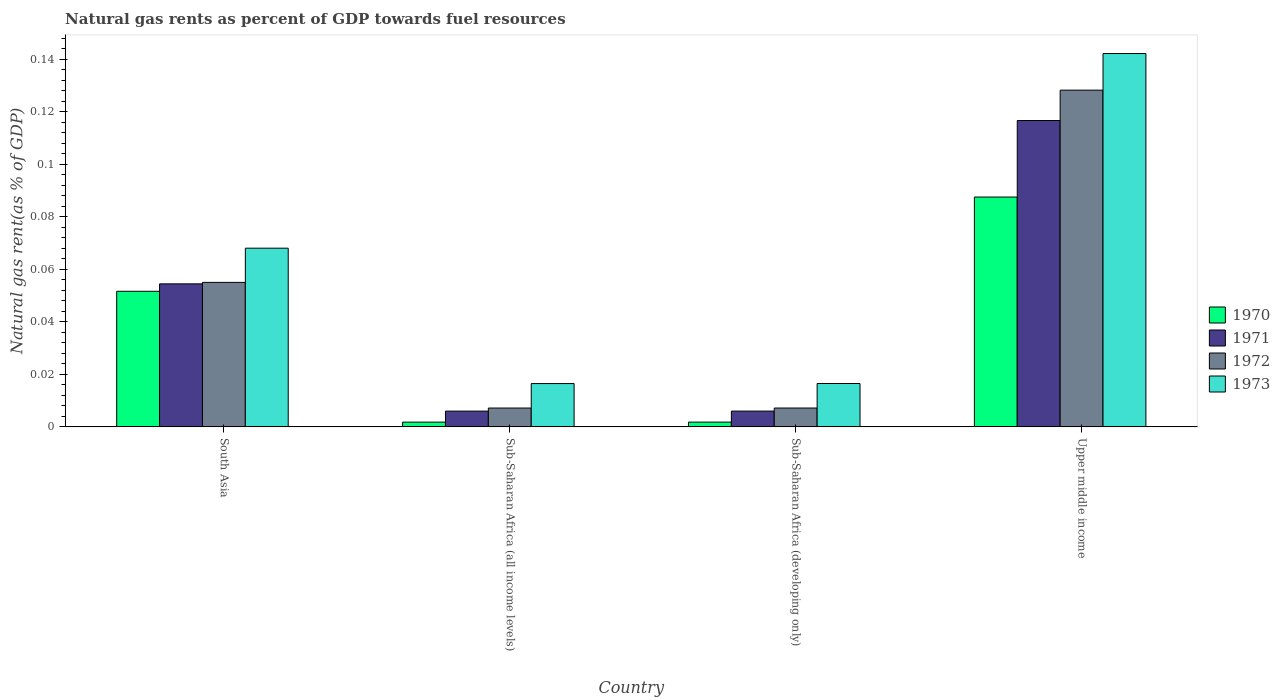How many different coloured bars are there?
Keep it short and to the point. 4. How many groups of bars are there?
Your response must be concise. 4. Are the number of bars per tick equal to the number of legend labels?
Provide a succinct answer. Yes. Are the number of bars on each tick of the X-axis equal?
Give a very brief answer. Yes. What is the label of the 1st group of bars from the left?
Keep it short and to the point. South Asia. What is the natural gas rent in 1971 in Sub-Saharan Africa (developing only)?
Give a very brief answer. 0.01. Across all countries, what is the maximum natural gas rent in 1973?
Your response must be concise. 0.14. Across all countries, what is the minimum natural gas rent in 1971?
Give a very brief answer. 0.01. In which country was the natural gas rent in 1973 maximum?
Your answer should be very brief. Upper middle income. In which country was the natural gas rent in 1971 minimum?
Provide a short and direct response. Sub-Saharan Africa (all income levels). What is the total natural gas rent in 1973 in the graph?
Your answer should be compact. 0.24. What is the difference between the natural gas rent in 1970 in South Asia and that in Upper middle income?
Provide a short and direct response. -0.04. What is the difference between the natural gas rent in 1972 in Sub-Saharan Africa (developing only) and the natural gas rent in 1973 in South Asia?
Your answer should be very brief. -0.06. What is the average natural gas rent in 1970 per country?
Offer a terse response. 0.04. What is the difference between the natural gas rent of/in 1971 and natural gas rent of/in 1970 in Upper middle income?
Provide a succinct answer. 0.03. What is the ratio of the natural gas rent in 1971 in Sub-Saharan Africa (all income levels) to that in Sub-Saharan Africa (developing only)?
Offer a very short reply. 1. Is the natural gas rent in 1973 in South Asia less than that in Sub-Saharan Africa (all income levels)?
Ensure brevity in your answer.  No. Is the difference between the natural gas rent in 1971 in South Asia and Upper middle income greater than the difference between the natural gas rent in 1970 in South Asia and Upper middle income?
Provide a short and direct response. No. What is the difference between the highest and the second highest natural gas rent in 1970?
Keep it short and to the point. 0.09. What is the difference between the highest and the lowest natural gas rent in 1971?
Your answer should be very brief. 0.11. Is the sum of the natural gas rent in 1971 in Sub-Saharan Africa (all income levels) and Upper middle income greater than the maximum natural gas rent in 1970 across all countries?
Your response must be concise. Yes. Is it the case that in every country, the sum of the natural gas rent in 1970 and natural gas rent in 1973 is greater than the sum of natural gas rent in 1971 and natural gas rent in 1972?
Ensure brevity in your answer.  No. What does the 2nd bar from the right in South Asia represents?
Keep it short and to the point. 1972. Are all the bars in the graph horizontal?
Your answer should be compact. No. What is the difference between two consecutive major ticks on the Y-axis?
Your response must be concise. 0.02. Are the values on the major ticks of Y-axis written in scientific E-notation?
Keep it short and to the point. No. Does the graph contain any zero values?
Your response must be concise. No. Does the graph contain grids?
Provide a short and direct response. No. Where does the legend appear in the graph?
Ensure brevity in your answer.  Center right. How many legend labels are there?
Your answer should be very brief. 4. How are the legend labels stacked?
Give a very brief answer. Vertical. What is the title of the graph?
Make the answer very short. Natural gas rents as percent of GDP towards fuel resources. What is the label or title of the X-axis?
Offer a terse response. Country. What is the label or title of the Y-axis?
Provide a succinct answer. Natural gas rent(as % of GDP). What is the Natural gas rent(as % of GDP) in 1970 in South Asia?
Offer a very short reply. 0.05. What is the Natural gas rent(as % of GDP) of 1971 in South Asia?
Keep it short and to the point. 0.05. What is the Natural gas rent(as % of GDP) in 1972 in South Asia?
Provide a short and direct response. 0.06. What is the Natural gas rent(as % of GDP) in 1973 in South Asia?
Give a very brief answer. 0.07. What is the Natural gas rent(as % of GDP) in 1970 in Sub-Saharan Africa (all income levels)?
Offer a terse response. 0. What is the Natural gas rent(as % of GDP) in 1971 in Sub-Saharan Africa (all income levels)?
Ensure brevity in your answer.  0.01. What is the Natural gas rent(as % of GDP) of 1972 in Sub-Saharan Africa (all income levels)?
Give a very brief answer. 0.01. What is the Natural gas rent(as % of GDP) in 1973 in Sub-Saharan Africa (all income levels)?
Your response must be concise. 0.02. What is the Natural gas rent(as % of GDP) in 1970 in Sub-Saharan Africa (developing only)?
Your answer should be very brief. 0. What is the Natural gas rent(as % of GDP) in 1971 in Sub-Saharan Africa (developing only)?
Your response must be concise. 0.01. What is the Natural gas rent(as % of GDP) of 1972 in Sub-Saharan Africa (developing only)?
Offer a terse response. 0.01. What is the Natural gas rent(as % of GDP) of 1973 in Sub-Saharan Africa (developing only)?
Provide a succinct answer. 0.02. What is the Natural gas rent(as % of GDP) in 1970 in Upper middle income?
Offer a terse response. 0.09. What is the Natural gas rent(as % of GDP) of 1971 in Upper middle income?
Your answer should be compact. 0.12. What is the Natural gas rent(as % of GDP) of 1972 in Upper middle income?
Offer a terse response. 0.13. What is the Natural gas rent(as % of GDP) of 1973 in Upper middle income?
Your answer should be compact. 0.14. Across all countries, what is the maximum Natural gas rent(as % of GDP) of 1970?
Make the answer very short. 0.09. Across all countries, what is the maximum Natural gas rent(as % of GDP) of 1971?
Offer a very short reply. 0.12. Across all countries, what is the maximum Natural gas rent(as % of GDP) of 1972?
Your answer should be compact. 0.13. Across all countries, what is the maximum Natural gas rent(as % of GDP) of 1973?
Your answer should be compact. 0.14. Across all countries, what is the minimum Natural gas rent(as % of GDP) in 1970?
Make the answer very short. 0. Across all countries, what is the minimum Natural gas rent(as % of GDP) of 1971?
Provide a short and direct response. 0.01. Across all countries, what is the minimum Natural gas rent(as % of GDP) of 1972?
Make the answer very short. 0.01. Across all countries, what is the minimum Natural gas rent(as % of GDP) of 1973?
Give a very brief answer. 0.02. What is the total Natural gas rent(as % of GDP) in 1970 in the graph?
Offer a terse response. 0.14. What is the total Natural gas rent(as % of GDP) of 1971 in the graph?
Offer a terse response. 0.18. What is the total Natural gas rent(as % of GDP) of 1972 in the graph?
Your answer should be compact. 0.2. What is the total Natural gas rent(as % of GDP) in 1973 in the graph?
Provide a succinct answer. 0.24. What is the difference between the Natural gas rent(as % of GDP) in 1970 in South Asia and that in Sub-Saharan Africa (all income levels)?
Your answer should be compact. 0.05. What is the difference between the Natural gas rent(as % of GDP) of 1971 in South Asia and that in Sub-Saharan Africa (all income levels)?
Your answer should be very brief. 0.05. What is the difference between the Natural gas rent(as % of GDP) in 1972 in South Asia and that in Sub-Saharan Africa (all income levels)?
Your answer should be very brief. 0.05. What is the difference between the Natural gas rent(as % of GDP) of 1973 in South Asia and that in Sub-Saharan Africa (all income levels)?
Your answer should be compact. 0.05. What is the difference between the Natural gas rent(as % of GDP) in 1970 in South Asia and that in Sub-Saharan Africa (developing only)?
Make the answer very short. 0.05. What is the difference between the Natural gas rent(as % of GDP) in 1971 in South Asia and that in Sub-Saharan Africa (developing only)?
Give a very brief answer. 0.05. What is the difference between the Natural gas rent(as % of GDP) in 1972 in South Asia and that in Sub-Saharan Africa (developing only)?
Provide a short and direct response. 0.05. What is the difference between the Natural gas rent(as % of GDP) of 1973 in South Asia and that in Sub-Saharan Africa (developing only)?
Ensure brevity in your answer.  0.05. What is the difference between the Natural gas rent(as % of GDP) of 1970 in South Asia and that in Upper middle income?
Keep it short and to the point. -0.04. What is the difference between the Natural gas rent(as % of GDP) in 1971 in South Asia and that in Upper middle income?
Your answer should be very brief. -0.06. What is the difference between the Natural gas rent(as % of GDP) in 1972 in South Asia and that in Upper middle income?
Provide a short and direct response. -0.07. What is the difference between the Natural gas rent(as % of GDP) of 1973 in South Asia and that in Upper middle income?
Keep it short and to the point. -0.07. What is the difference between the Natural gas rent(as % of GDP) in 1971 in Sub-Saharan Africa (all income levels) and that in Sub-Saharan Africa (developing only)?
Keep it short and to the point. -0. What is the difference between the Natural gas rent(as % of GDP) of 1972 in Sub-Saharan Africa (all income levels) and that in Sub-Saharan Africa (developing only)?
Keep it short and to the point. -0. What is the difference between the Natural gas rent(as % of GDP) of 1973 in Sub-Saharan Africa (all income levels) and that in Sub-Saharan Africa (developing only)?
Provide a succinct answer. -0. What is the difference between the Natural gas rent(as % of GDP) in 1970 in Sub-Saharan Africa (all income levels) and that in Upper middle income?
Ensure brevity in your answer.  -0.09. What is the difference between the Natural gas rent(as % of GDP) of 1971 in Sub-Saharan Africa (all income levels) and that in Upper middle income?
Offer a very short reply. -0.11. What is the difference between the Natural gas rent(as % of GDP) in 1972 in Sub-Saharan Africa (all income levels) and that in Upper middle income?
Ensure brevity in your answer.  -0.12. What is the difference between the Natural gas rent(as % of GDP) of 1973 in Sub-Saharan Africa (all income levels) and that in Upper middle income?
Your response must be concise. -0.13. What is the difference between the Natural gas rent(as % of GDP) in 1970 in Sub-Saharan Africa (developing only) and that in Upper middle income?
Offer a terse response. -0.09. What is the difference between the Natural gas rent(as % of GDP) in 1971 in Sub-Saharan Africa (developing only) and that in Upper middle income?
Make the answer very short. -0.11. What is the difference between the Natural gas rent(as % of GDP) in 1972 in Sub-Saharan Africa (developing only) and that in Upper middle income?
Keep it short and to the point. -0.12. What is the difference between the Natural gas rent(as % of GDP) of 1973 in Sub-Saharan Africa (developing only) and that in Upper middle income?
Your answer should be compact. -0.13. What is the difference between the Natural gas rent(as % of GDP) of 1970 in South Asia and the Natural gas rent(as % of GDP) of 1971 in Sub-Saharan Africa (all income levels)?
Provide a short and direct response. 0.05. What is the difference between the Natural gas rent(as % of GDP) of 1970 in South Asia and the Natural gas rent(as % of GDP) of 1972 in Sub-Saharan Africa (all income levels)?
Offer a terse response. 0.04. What is the difference between the Natural gas rent(as % of GDP) of 1970 in South Asia and the Natural gas rent(as % of GDP) of 1973 in Sub-Saharan Africa (all income levels)?
Provide a short and direct response. 0.04. What is the difference between the Natural gas rent(as % of GDP) in 1971 in South Asia and the Natural gas rent(as % of GDP) in 1972 in Sub-Saharan Africa (all income levels)?
Your response must be concise. 0.05. What is the difference between the Natural gas rent(as % of GDP) in 1971 in South Asia and the Natural gas rent(as % of GDP) in 1973 in Sub-Saharan Africa (all income levels)?
Ensure brevity in your answer.  0.04. What is the difference between the Natural gas rent(as % of GDP) of 1972 in South Asia and the Natural gas rent(as % of GDP) of 1973 in Sub-Saharan Africa (all income levels)?
Your response must be concise. 0.04. What is the difference between the Natural gas rent(as % of GDP) of 1970 in South Asia and the Natural gas rent(as % of GDP) of 1971 in Sub-Saharan Africa (developing only)?
Offer a terse response. 0.05. What is the difference between the Natural gas rent(as % of GDP) of 1970 in South Asia and the Natural gas rent(as % of GDP) of 1972 in Sub-Saharan Africa (developing only)?
Make the answer very short. 0.04. What is the difference between the Natural gas rent(as % of GDP) of 1970 in South Asia and the Natural gas rent(as % of GDP) of 1973 in Sub-Saharan Africa (developing only)?
Offer a very short reply. 0.04. What is the difference between the Natural gas rent(as % of GDP) of 1971 in South Asia and the Natural gas rent(as % of GDP) of 1972 in Sub-Saharan Africa (developing only)?
Offer a terse response. 0.05. What is the difference between the Natural gas rent(as % of GDP) in 1971 in South Asia and the Natural gas rent(as % of GDP) in 1973 in Sub-Saharan Africa (developing only)?
Give a very brief answer. 0.04. What is the difference between the Natural gas rent(as % of GDP) of 1972 in South Asia and the Natural gas rent(as % of GDP) of 1973 in Sub-Saharan Africa (developing only)?
Make the answer very short. 0.04. What is the difference between the Natural gas rent(as % of GDP) of 1970 in South Asia and the Natural gas rent(as % of GDP) of 1971 in Upper middle income?
Ensure brevity in your answer.  -0.07. What is the difference between the Natural gas rent(as % of GDP) of 1970 in South Asia and the Natural gas rent(as % of GDP) of 1972 in Upper middle income?
Ensure brevity in your answer.  -0.08. What is the difference between the Natural gas rent(as % of GDP) of 1970 in South Asia and the Natural gas rent(as % of GDP) of 1973 in Upper middle income?
Keep it short and to the point. -0.09. What is the difference between the Natural gas rent(as % of GDP) in 1971 in South Asia and the Natural gas rent(as % of GDP) in 1972 in Upper middle income?
Provide a succinct answer. -0.07. What is the difference between the Natural gas rent(as % of GDP) in 1971 in South Asia and the Natural gas rent(as % of GDP) in 1973 in Upper middle income?
Keep it short and to the point. -0.09. What is the difference between the Natural gas rent(as % of GDP) of 1972 in South Asia and the Natural gas rent(as % of GDP) of 1973 in Upper middle income?
Offer a very short reply. -0.09. What is the difference between the Natural gas rent(as % of GDP) of 1970 in Sub-Saharan Africa (all income levels) and the Natural gas rent(as % of GDP) of 1971 in Sub-Saharan Africa (developing only)?
Ensure brevity in your answer.  -0. What is the difference between the Natural gas rent(as % of GDP) of 1970 in Sub-Saharan Africa (all income levels) and the Natural gas rent(as % of GDP) of 1972 in Sub-Saharan Africa (developing only)?
Offer a very short reply. -0.01. What is the difference between the Natural gas rent(as % of GDP) in 1970 in Sub-Saharan Africa (all income levels) and the Natural gas rent(as % of GDP) in 1973 in Sub-Saharan Africa (developing only)?
Your response must be concise. -0.01. What is the difference between the Natural gas rent(as % of GDP) in 1971 in Sub-Saharan Africa (all income levels) and the Natural gas rent(as % of GDP) in 1972 in Sub-Saharan Africa (developing only)?
Provide a succinct answer. -0. What is the difference between the Natural gas rent(as % of GDP) of 1971 in Sub-Saharan Africa (all income levels) and the Natural gas rent(as % of GDP) of 1973 in Sub-Saharan Africa (developing only)?
Your answer should be compact. -0.01. What is the difference between the Natural gas rent(as % of GDP) in 1972 in Sub-Saharan Africa (all income levels) and the Natural gas rent(as % of GDP) in 1973 in Sub-Saharan Africa (developing only)?
Provide a succinct answer. -0.01. What is the difference between the Natural gas rent(as % of GDP) in 1970 in Sub-Saharan Africa (all income levels) and the Natural gas rent(as % of GDP) in 1971 in Upper middle income?
Ensure brevity in your answer.  -0.11. What is the difference between the Natural gas rent(as % of GDP) in 1970 in Sub-Saharan Africa (all income levels) and the Natural gas rent(as % of GDP) in 1972 in Upper middle income?
Your response must be concise. -0.13. What is the difference between the Natural gas rent(as % of GDP) in 1970 in Sub-Saharan Africa (all income levels) and the Natural gas rent(as % of GDP) in 1973 in Upper middle income?
Keep it short and to the point. -0.14. What is the difference between the Natural gas rent(as % of GDP) in 1971 in Sub-Saharan Africa (all income levels) and the Natural gas rent(as % of GDP) in 1972 in Upper middle income?
Your response must be concise. -0.12. What is the difference between the Natural gas rent(as % of GDP) of 1971 in Sub-Saharan Africa (all income levels) and the Natural gas rent(as % of GDP) of 1973 in Upper middle income?
Provide a succinct answer. -0.14. What is the difference between the Natural gas rent(as % of GDP) in 1972 in Sub-Saharan Africa (all income levels) and the Natural gas rent(as % of GDP) in 1973 in Upper middle income?
Your answer should be compact. -0.14. What is the difference between the Natural gas rent(as % of GDP) in 1970 in Sub-Saharan Africa (developing only) and the Natural gas rent(as % of GDP) in 1971 in Upper middle income?
Your answer should be very brief. -0.11. What is the difference between the Natural gas rent(as % of GDP) of 1970 in Sub-Saharan Africa (developing only) and the Natural gas rent(as % of GDP) of 1972 in Upper middle income?
Offer a very short reply. -0.13. What is the difference between the Natural gas rent(as % of GDP) in 1970 in Sub-Saharan Africa (developing only) and the Natural gas rent(as % of GDP) in 1973 in Upper middle income?
Give a very brief answer. -0.14. What is the difference between the Natural gas rent(as % of GDP) of 1971 in Sub-Saharan Africa (developing only) and the Natural gas rent(as % of GDP) of 1972 in Upper middle income?
Offer a terse response. -0.12. What is the difference between the Natural gas rent(as % of GDP) in 1971 in Sub-Saharan Africa (developing only) and the Natural gas rent(as % of GDP) in 1973 in Upper middle income?
Make the answer very short. -0.14. What is the difference between the Natural gas rent(as % of GDP) of 1972 in Sub-Saharan Africa (developing only) and the Natural gas rent(as % of GDP) of 1973 in Upper middle income?
Make the answer very short. -0.14. What is the average Natural gas rent(as % of GDP) in 1970 per country?
Provide a succinct answer. 0.04. What is the average Natural gas rent(as % of GDP) in 1971 per country?
Give a very brief answer. 0.05. What is the average Natural gas rent(as % of GDP) in 1972 per country?
Your answer should be very brief. 0.05. What is the average Natural gas rent(as % of GDP) of 1973 per country?
Provide a succinct answer. 0.06. What is the difference between the Natural gas rent(as % of GDP) in 1970 and Natural gas rent(as % of GDP) in 1971 in South Asia?
Make the answer very short. -0. What is the difference between the Natural gas rent(as % of GDP) of 1970 and Natural gas rent(as % of GDP) of 1972 in South Asia?
Keep it short and to the point. -0. What is the difference between the Natural gas rent(as % of GDP) of 1970 and Natural gas rent(as % of GDP) of 1973 in South Asia?
Your answer should be compact. -0.02. What is the difference between the Natural gas rent(as % of GDP) of 1971 and Natural gas rent(as % of GDP) of 1972 in South Asia?
Offer a very short reply. -0. What is the difference between the Natural gas rent(as % of GDP) in 1971 and Natural gas rent(as % of GDP) in 1973 in South Asia?
Your response must be concise. -0.01. What is the difference between the Natural gas rent(as % of GDP) in 1972 and Natural gas rent(as % of GDP) in 1973 in South Asia?
Offer a terse response. -0.01. What is the difference between the Natural gas rent(as % of GDP) of 1970 and Natural gas rent(as % of GDP) of 1971 in Sub-Saharan Africa (all income levels)?
Your answer should be very brief. -0. What is the difference between the Natural gas rent(as % of GDP) of 1970 and Natural gas rent(as % of GDP) of 1972 in Sub-Saharan Africa (all income levels)?
Provide a short and direct response. -0.01. What is the difference between the Natural gas rent(as % of GDP) of 1970 and Natural gas rent(as % of GDP) of 1973 in Sub-Saharan Africa (all income levels)?
Offer a terse response. -0.01. What is the difference between the Natural gas rent(as % of GDP) of 1971 and Natural gas rent(as % of GDP) of 1972 in Sub-Saharan Africa (all income levels)?
Your response must be concise. -0. What is the difference between the Natural gas rent(as % of GDP) of 1971 and Natural gas rent(as % of GDP) of 1973 in Sub-Saharan Africa (all income levels)?
Your answer should be compact. -0.01. What is the difference between the Natural gas rent(as % of GDP) of 1972 and Natural gas rent(as % of GDP) of 1973 in Sub-Saharan Africa (all income levels)?
Your response must be concise. -0.01. What is the difference between the Natural gas rent(as % of GDP) in 1970 and Natural gas rent(as % of GDP) in 1971 in Sub-Saharan Africa (developing only)?
Provide a short and direct response. -0. What is the difference between the Natural gas rent(as % of GDP) in 1970 and Natural gas rent(as % of GDP) in 1972 in Sub-Saharan Africa (developing only)?
Your response must be concise. -0.01. What is the difference between the Natural gas rent(as % of GDP) in 1970 and Natural gas rent(as % of GDP) in 1973 in Sub-Saharan Africa (developing only)?
Ensure brevity in your answer.  -0.01. What is the difference between the Natural gas rent(as % of GDP) of 1971 and Natural gas rent(as % of GDP) of 1972 in Sub-Saharan Africa (developing only)?
Offer a very short reply. -0. What is the difference between the Natural gas rent(as % of GDP) in 1971 and Natural gas rent(as % of GDP) in 1973 in Sub-Saharan Africa (developing only)?
Offer a very short reply. -0.01. What is the difference between the Natural gas rent(as % of GDP) in 1972 and Natural gas rent(as % of GDP) in 1973 in Sub-Saharan Africa (developing only)?
Provide a succinct answer. -0.01. What is the difference between the Natural gas rent(as % of GDP) of 1970 and Natural gas rent(as % of GDP) of 1971 in Upper middle income?
Offer a terse response. -0.03. What is the difference between the Natural gas rent(as % of GDP) in 1970 and Natural gas rent(as % of GDP) in 1972 in Upper middle income?
Provide a short and direct response. -0.04. What is the difference between the Natural gas rent(as % of GDP) in 1970 and Natural gas rent(as % of GDP) in 1973 in Upper middle income?
Provide a succinct answer. -0.05. What is the difference between the Natural gas rent(as % of GDP) of 1971 and Natural gas rent(as % of GDP) of 1972 in Upper middle income?
Your answer should be compact. -0.01. What is the difference between the Natural gas rent(as % of GDP) of 1971 and Natural gas rent(as % of GDP) of 1973 in Upper middle income?
Keep it short and to the point. -0.03. What is the difference between the Natural gas rent(as % of GDP) of 1972 and Natural gas rent(as % of GDP) of 1973 in Upper middle income?
Give a very brief answer. -0.01. What is the ratio of the Natural gas rent(as % of GDP) of 1970 in South Asia to that in Sub-Saharan Africa (all income levels)?
Provide a short and direct response. 28.57. What is the ratio of the Natural gas rent(as % of GDP) in 1971 in South Asia to that in Sub-Saharan Africa (all income levels)?
Keep it short and to the point. 9.07. What is the ratio of the Natural gas rent(as % of GDP) of 1972 in South Asia to that in Sub-Saharan Africa (all income levels)?
Offer a terse response. 7.67. What is the ratio of the Natural gas rent(as % of GDP) in 1973 in South Asia to that in Sub-Saharan Africa (all income levels)?
Provide a short and direct response. 4.13. What is the ratio of the Natural gas rent(as % of GDP) in 1970 in South Asia to that in Sub-Saharan Africa (developing only)?
Ensure brevity in your answer.  28.53. What is the ratio of the Natural gas rent(as % of GDP) in 1971 in South Asia to that in Sub-Saharan Africa (developing only)?
Offer a terse response. 9.06. What is the ratio of the Natural gas rent(as % of GDP) in 1972 in South Asia to that in Sub-Saharan Africa (developing only)?
Ensure brevity in your answer.  7.66. What is the ratio of the Natural gas rent(as % of GDP) of 1973 in South Asia to that in Sub-Saharan Africa (developing only)?
Give a very brief answer. 4.12. What is the ratio of the Natural gas rent(as % of GDP) in 1970 in South Asia to that in Upper middle income?
Keep it short and to the point. 0.59. What is the ratio of the Natural gas rent(as % of GDP) in 1971 in South Asia to that in Upper middle income?
Provide a short and direct response. 0.47. What is the ratio of the Natural gas rent(as % of GDP) in 1972 in South Asia to that in Upper middle income?
Offer a very short reply. 0.43. What is the ratio of the Natural gas rent(as % of GDP) in 1973 in South Asia to that in Upper middle income?
Give a very brief answer. 0.48. What is the ratio of the Natural gas rent(as % of GDP) of 1970 in Sub-Saharan Africa (all income levels) to that in Sub-Saharan Africa (developing only)?
Offer a very short reply. 1. What is the ratio of the Natural gas rent(as % of GDP) of 1971 in Sub-Saharan Africa (all income levels) to that in Sub-Saharan Africa (developing only)?
Ensure brevity in your answer.  1. What is the ratio of the Natural gas rent(as % of GDP) in 1972 in Sub-Saharan Africa (all income levels) to that in Sub-Saharan Africa (developing only)?
Provide a short and direct response. 1. What is the ratio of the Natural gas rent(as % of GDP) of 1973 in Sub-Saharan Africa (all income levels) to that in Sub-Saharan Africa (developing only)?
Give a very brief answer. 1. What is the ratio of the Natural gas rent(as % of GDP) in 1970 in Sub-Saharan Africa (all income levels) to that in Upper middle income?
Keep it short and to the point. 0.02. What is the ratio of the Natural gas rent(as % of GDP) in 1971 in Sub-Saharan Africa (all income levels) to that in Upper middle income?
Offer a very short reply. 0.05. What is the ratio of the Natural gas rent(as % of GDP) of 1972 in Sub-Saharan Africa (all income levels) to that in Upper middle income?
Offer a terse response. 0.06. What is the ratio of the Natural gas rent(as % of GDP) in 1973 in Sub-Saharan Africa (all income levels) to that in Upper middle income?
Your answer should be very brief. 0.12. What is the ratio of the Natural gas rent(as % of GDP) of 1970 in Sub-Saharan Africa (developing only) to that in Upper middle income?
Provide a succinct answer. 0.02. What is the ratio of the Natural gas rent(as % of GDP) in 1971 in Sub-Saharan Africa (developing only) to that in Upper middle income?
Offer a very short reply. 0.05. What is the ratio of the Natural gas rent(as % of GDP) in 1972 in Sub-Saharan Africa (developing only) to that in Upper middle income?
Offer a very short reply. 0.06. What is the ratio of the Natural gas rent(as % of GDP) in 1973 in Sub-Saharan Africa (developing only) to that in Upper middle income?
Your answer should be compact. 0.12. What is the difference between the highest and the second highest Natural gas rent(as % of GDP) in 1970?
Your response must be concise. 0.04. What is the difference between the highest and the second highest Natural gas rent(as % of GDP) of 1971?
Ensure brevity in your answer.  0.06. What is the difference between the highest and the second highest Natural gas rent(as % of GDP) of 1972?
Keep it short and to the point. 0.07. What is the difference between the highest and the second highest Natural gas rent(as % of GDP) of 1973?
Provide a short and direct response. 0.07. What is the difference between the highest and the lowest Natural gas rent(as % of GDP) of 1970?
Offer a terse response. 0.09. What is the difference between the highest and the lowest Natural gas rent(as % of GDP) in 1971?
Keep it short and to the point. 0.11. What is the difference between the highest and the lowest Natural gas rent(as % of GDP) in 1972?
Your answer should be very brief. 0.12. What is the difference between the highest and the lowest Natural gas rent(as % of GDP) of 1973?
Offer a very short reply. 0.13. 